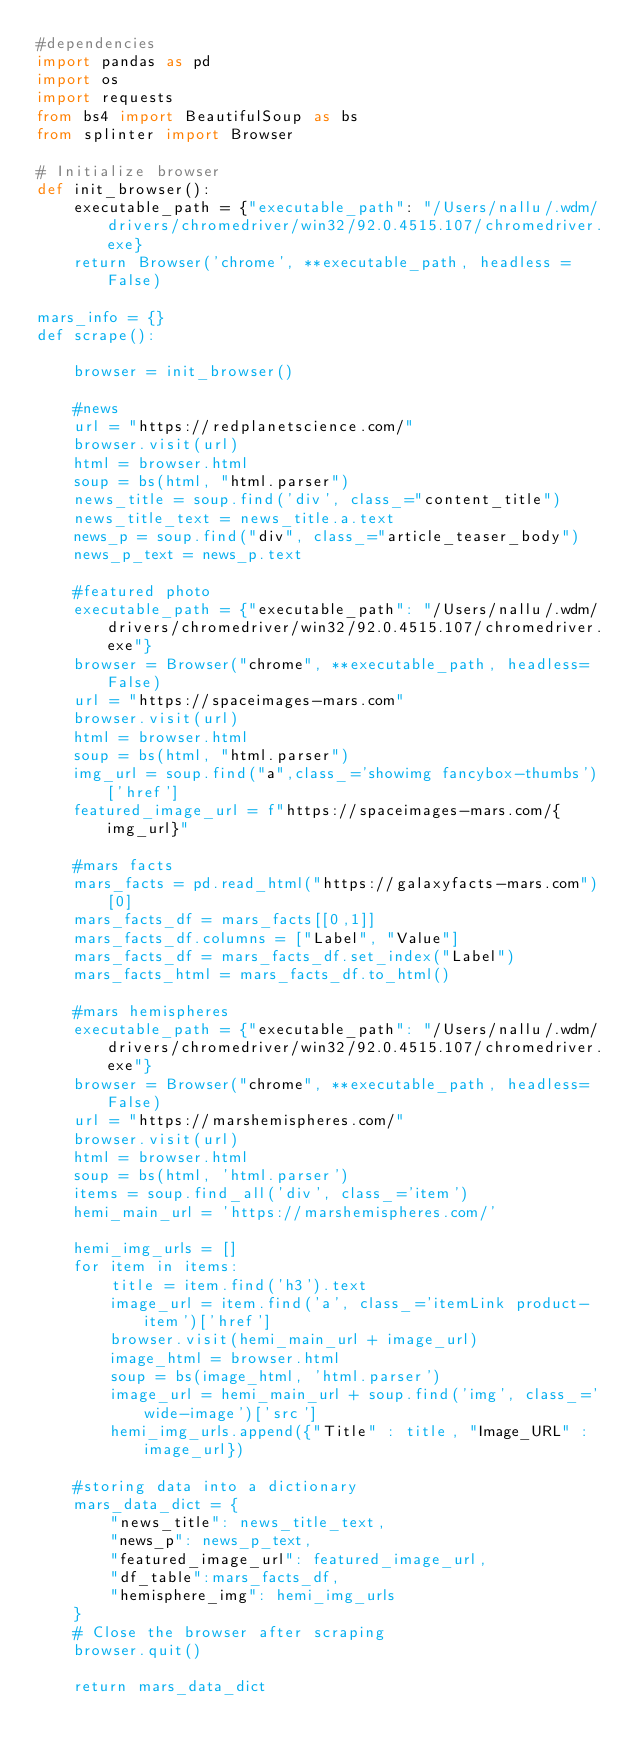Convert code to text. <code><loc_0><loc_0><loc_500><loc_500><_Python_>#dependencies
import pandas as pd
import os
import requests
from bs4 import BeautifulSoup as bs
from splinter import Browser

# Initialize browser
def init_browser():
    executable_path = {"executable_path": "/Users/nallu/.wdm/drivers/chromedriver/win32/92.0.4515.107/chromedriver.exe}
    return Browser('chrome', **executable_path, headless = False)
    
mars_info = {}
def scrape():
   
    browser = init_browser()
                       
    #news
    url = "https://redplanetscience.com/"
    browser.visit(url)
    html = browser.html
    soup = bs(html, "html.parser")
    news_title = soup.find('div', class_="content_title")
    news_title_text = news_title.a.text
    news_p = soup.find("div", class_="article_teaser_body")
    news_p_text = news_p.text
                       
    #featured photo
    executable_path = {"executable_path": "/Users/nallu/.wdm/drivers/chromedriver/win32/92.0.4515.107/chromedriver.exe"}
    browser = Browser("chrome", **executable_path, headless=False)
    url = "https://spaceimages-mars.com"
    browser.visit(url)
    html = browser.html
    soup = bs(html, "html.parser")
    img_url = soup.find("a",class_='showimg fancybox-thumbs')['href']
    featured_image_url = f"https://spaceimages-mars.com/{img_url}"
                       
    #mars facts
    mars_facts = pd.read_html("https://galaxyfacts-mars.com")[0]
    mars_facts_df = mars_facts[[0,1]]
    mars_facts_df.columns = ["Label", "Value"]
    mars_facts_df = mars_facts_df.set_index("Label")
    mars_facts_html = mars_facts_df.to_html()
    
    #mars hemispheres
    executable_path = {"executable_path": "/Users/nallu/.wdm/drivers/chromedriver/win32/92.0.4515.107/chromedriver.exe"}
    browser = Browser("chrome", **executable_path, headless=False)
    url = "https://marshemispheres.com/"
    browser.visit(url)
    html = browser.html
    soup = bs(html, 'html.parser')
    items = soup.find_all('div', class_='item')
    hemi_main_url = 'https://marshemispheres.com/'

    hemi_img_urls = []
    for item in items: 
        title = item.find('h3').text
        image_url = item.find('a', class_='itemLink product-item')['href']
        browser.visit(hemi_main_url + image_url)
        image_html = browser.html
        soup = bs(image_html, 'html.parser')
        image_url = hemi_main_url + soup.find('img', class_='wide-image')['src']
        hemi_img_urls.append({"Title" : title, "Image_URL" : image_url})
                       
    #storing data into a dictionary
    mars_data_dict = {
        "news_title": news_title_text,
        "news_p": news_p_text,
        "featured_image_url": featured_image_url,
        "df_table":mars_facts_df,
        "hemisphere_img": hemi_img_urls
    }
    # Close the browser after scraping
    browser.quit()
                       
    return mars_data_dict</code> 